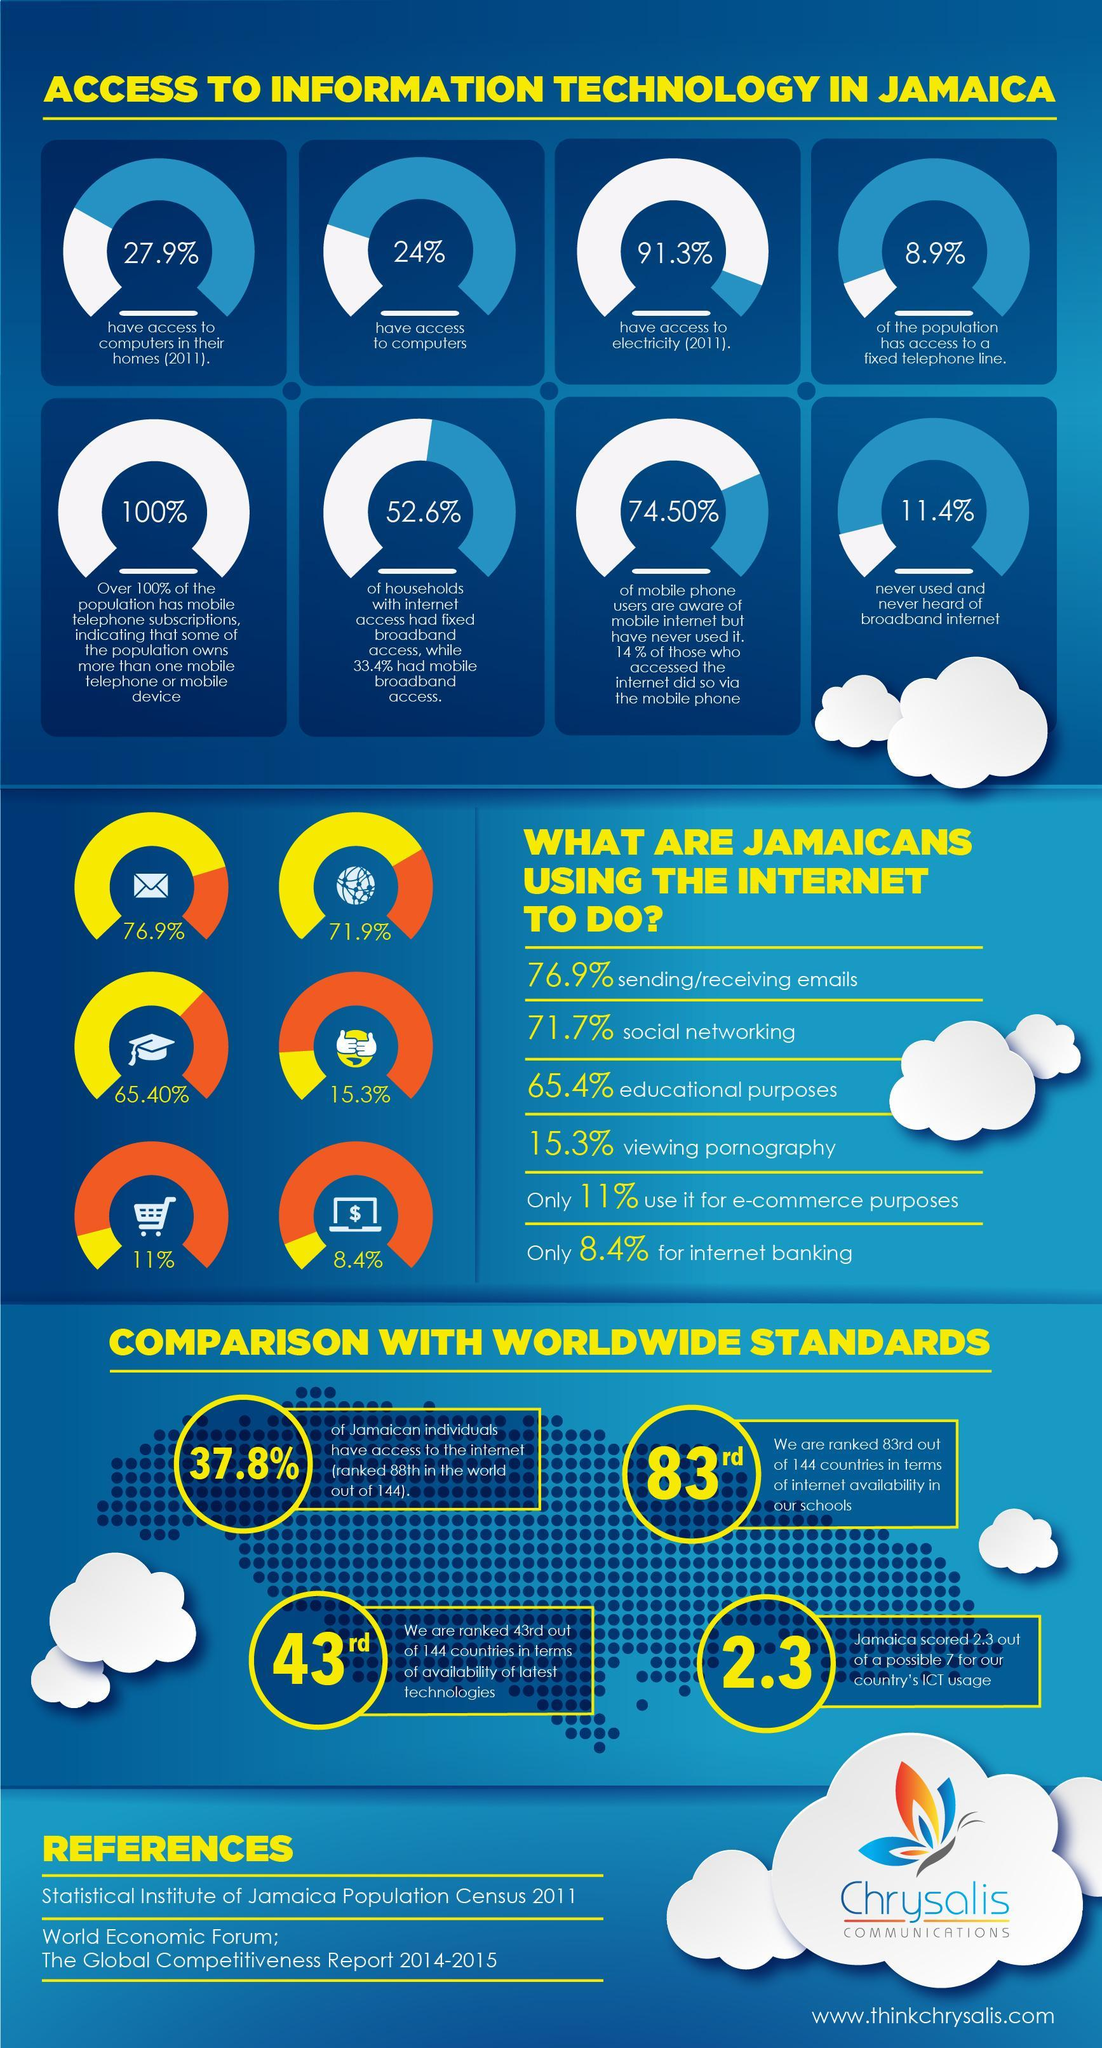What is Jamaica's score for the country's  ICT usage?
Answer the question with a short phrase. 2.3 What percentage of Jamaicans use the internet for viewing pornography? 15.3% What percentage of Jamaicans do not have access to computers in their home in 2011? 72.1% What percentage of Jamaican population has access to a fixed telephone line? 8.9% What percentage of Jamaicans have access to electricity in 2011? 91.3% Which is the most performed task by the Jamaicans using the internet? sending/receiving emails What percentage of Jamaicans use the internet for social networking? 71.7% Which is the least performed task by the Jamaicans using the internet? internet banking 